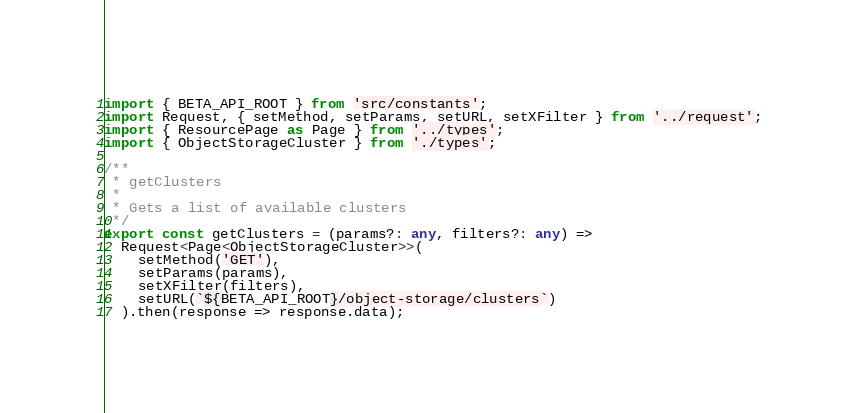Convert code to text. <code><loc_0><loc_0><loc_500><loc_500><_TypeScript_>import { BETA_API_ROOT } from 'src/constants';
import Request, { setMethod, setParams, setURL, setXFilter } from '../request';
import { ResourcePage as Page } from '../types';
import { ObjectStorageCluster } from './types';

/**
 * getClusters
 *
 * Gets a list of available clusters
 */
export const getClusters = (params?: any, filters?: any) =>
  Request<Page<ObjectStorageCluster>>(
    setMethod('GET'),
    setParams(params),
    setXFilter(filters),
    setURL(`${BETA_API_ROOT}/object-storage/clusters`)
  ).then(response => response.data);
</code> 